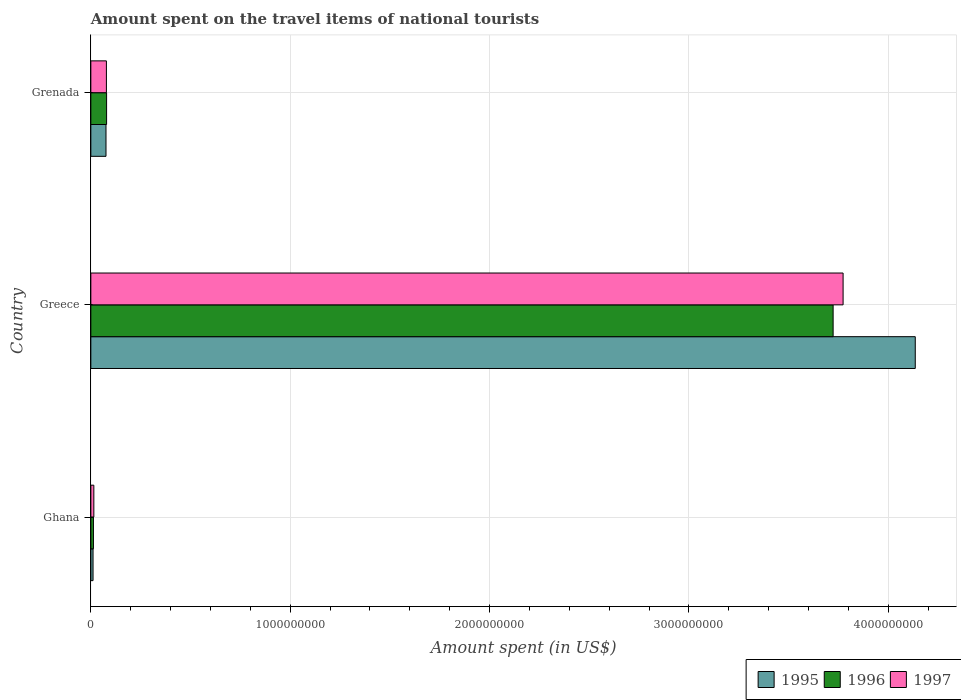How many different coloured bars are there?
Ensure brevity in your answer.  3. How many groups of bars are there?
Offer a very short reply. 3. How many bars are there on the 1st tick from the top?
Give a very brief answer. 3. How many bars are there on the 1st tick from the bottom?
Ensure brevity in your answer.  3. What is the label of the 1st group of bars from the top?
Offer a very short reply. Grenada. In how many cases, is the number of bars for a given country not equal to the number of legend labels?
Offer a terse response. 0. What is the amount spent on the travel items of national tourists in 1997 in Ghana?
Ensure brevity in your answer.  1.50e+07. Across all countries, what is the maximum amount spent on the travel items of national tourists in 1996?
Keep it short and to the point. 3.72e+09. Across all countries, what is the minimum amount spent on the travel items of national tourists in 1996?
Keep it short and to the point. 1.30e+07. In which country was the amount spent on the travel items of national tourists in 1997 minimum?
Provide a short and direct response. Ghana. What is the total amount spent on the travel items of national tourists in 1996 in the graph?
Make the answer very short. 3.82e+09. What is the difference between the amount spent on the travel items of national tourists in 1995 in Ghana and that in Greece?
Provide a succinct answer. -4.12e+09. What is the difference between the amount spent on the travel items of national tourists in 1997 in Greece and the amount spent on the travel items of national tourists in 1995 in Ghana?
Provide a succinct answer. 3.76e+09. What is the average amount spent on the travel items of national tourists in 1996 per country?
Offer a terse response. 1.27e+09. In how many countries, is the amount spent on the travel items of national tourists in 1996 greater than 1800000000 US$?
Your response must be concise. 1. What is the ratio of the amount spent on the travel items of national tourists in 1997 in Greece to that in Grenada?
Provide a short and direct response. 48.37. Is the amount spent on the travel items of national tourists in 1996 in Ghana less than that in Grenada?
Keep it short and to the point. Yes. What is the difference between the highest and the second highest amount spent on the travel items of national tourists in 1996?
Your answer should be very brief. 3.64e+09. What is the difference between the highest and the lowest amount spent on the travel items of national tourists in 1996?
Your response must be concise. 3.71e+09. In how many countries, is the amount spent on the travel items of national tourists in 1996 greater than the average amount spent on the travel items of national tourists in 1996 taken over all countries?
Provide a short and direct response. 1. What does the 2nd bar from the bottom in Ghana represents?
Your response must be concise. 1996. Are all the bars in the graph horizontal?
Offer a terse response. Yes. What is the difference between two consecutive major ticks on the X-axis?
Your answer should be very brief. 1.00e+09. Does the graph contain any zero values?
Your answer should be very brief. No. Does the graph contain grids?
Provide a short and direct response. Yes. How many legend labels are there?
Offer a terse response. 3. How are the legend labels stacked?
Make the answer very short. Horizontal. What is the title of the graph?
Provide a succinct answer. Amount spent on the travel items of national tourists. What is the label or title of the X-axis?
Keep it short and to the point. Amount spent (in US$). What is the Amount spent (in US$) of 1995 in Ghana?
Your answer should be very brief. 1.10e+07. What is the Amount spent (in US$) in 1996 in Ghana?
Give a very brief answer. 1.30e+07. What is the Amount spent (in US$) in 1997 in Ghana?
Your response must be concise. 1.50e+07. What is the Amount spent (in US$) in 1995 in Greece?
Ensure brevity in your answer.  4.14e+09. What is the Amount spent (in US$) of 1996 in Greece?
Offer a terse response. 3.72e+09. What is the Amount spent (in US$) in 1997 in Greece?
Your response must be concise. 3.77e+09. What is the Amount spent (in US$) of 1995 in Grenada?
Your response must be concise. 7.60e+07. What is the Amount spent (in US$) of 1996 in Grenada?
Offer a very short reply. 7.90e+07. What is the Amount spent (in US$) of 1997 in Grenada?
Your answer should be compact. 7.80e+07. Across all countries, what is the maximum Amount spent (in US$) of 1995?
Ensure brevity in your answer.  4.14e+09. Across all countries, what is the maximum Amount spent (in US$) in 1996?
Offer a very short reply. 3.72e+09. Across all countries, what is the maximum Amount spent (in US$) in 1997?
Your response must be concise. 3.77e+09. Across all countries, what is the minimum Amount spent (in US$) in 1995?
Your response must be concise. 1.10e+07. Across all countries, what is the minimum Amount spent (in US$) of 1996?
Give a very brief answer. 1.30e+07. Across all countries, what is the minimum Amount spent (in US$) in 1997?
Provide a short and direct response. 1.50e+07. What is the total Amount spent (in US$) of 1995 in the graph?
Give a very brief answer. 4.22e+09. What is the total Amount spent (in US$) in 1996 in the graph?
Your answer should be very brief. 3.82e+09. What is the total Amount spent (in US$) of 1997 in the graph?
Your response must be concise. 3.87e+09. What is the difference between the Amount spent (in US$) in 1995 in Ghana and that in Greece?
Your answer should be very brief. -4.12e+09. What is the difference between the Amount spent (in US$) of 1996 in Ghana and that in Greece?
Keep it short and to the point. -3.71e+09. What is the difference between the Amount spent (in US$) in 1997 in Ghana and that in Greece?
Ensure brevity in your answer.  -3.76e+09. What is the difference between the Amount spent (in US$) of 1995 in Ghana and that in Grenada?
Provide a short and direct response. -6.50e+07. What is the difference between the Amount spent (in US$) of 1996 in Ghana and that in Grenada?
Make the answer very short. -6.60e+07. What is the difference between the Amount spent (in US$) in 1997 in Ghana and that in Grenada?
Your answer should be compact. -6.30e+07. What is the difference between the Amount spent (in US$) in 1995 in Greece and that in Grenada?
Your answer should be compact. 4.06e+09. What is the difference between the Amount spent (in US$) of 1996 in Greece and that in Grenada?
Make the answer very short. 3.64e+09. What is the difference between the Amount spent (in US$) of 1997 in Greece and that in Grenada?
Your answer should be compact. 3.70e+09. What is the difference between the Amount spent (in US$) in 1995 in Ghana and the Amount spent (in US$) in 1996 in Greece?
Your answer should be very brief. -3.71e+09. What is the difference between the Amount spent (in US$) in 1995 in Ghana and the Amount spent (in US$) in 1997 in Greece?
Offer a terse response. -3.76e+09. What is the difference between the Amount spent (in US$) in 1996 in Ghana and the Amount spent (in US$) in 1997 in Greece?
Give a very brief answer. -3.76e+09. What is the difference between the Amount spent (in US$) of 1995 in Ghana and the Amount spent (in US$) of 1996 in Grenada?
Provide a short and direct response. -6.80e+07. What is the difference between the Amount spent (in US$) of 1995 in Ghana and the Amount spent (in US$) of 1997 in Grenada?
Your response must be concise. -6.70e+07. What is the difference between the Amount spent (in US$) of 1996 in Ghana and the Amount spent (in US$) of 1997 in Grenada?
Provide a succinct answer. -6.50e+07. What is the difference between the Amount spent (in US$) of 1995 in Greece and the Amount spent (in US$) of 1996 in Grenada?
Make the answer very short. 4.06e+09. What is the difference between the Amount spent (in US$) of 1995 in Greece and the Amount spent (in US$) of 1997 in Grenada?
Your response must be concise. 4.06e+09. What is the difference between the Amount spent (in US$) of 1996 in Greece and the Amount spent (in US$) of 1997 in Grenada?
Provide a short and direct response. 3.64e+09. What is the average Amount spent (in US$) in 1995 per country?
Offer a terse response. 1.41e+09. What is the average Amount spent (in US$) in 1996 per country?
Provide a succinct answer. 1.27e+09. What is the average Amount spent (in US$) in 1997 per country?
Give a very brief answer. 1.29e+09. What is the difference between the Amount spent (in US$) of 1995 and Amount spent (in US$) of 1996 in Ghana?
Keep it short and to the point. -2.00e+06. What is the difference between the Amount spent (in US$) in 1995 and Amount spent (in US$) in 1997 in Ghana?
Your answer should be very brief. -4.00e+06. What is the difference between the Amount spent (in US$) of 1995 and Amount spent (in US$) of 1996 in Greece?
Your answer should be compact. 4.12e+08. What is the difference between the Amount spent (in US$) in 1995 and Amount spent (in US$) in 1997 in Greece?
Your answer should be very brief. 3.62e+08. What is the difference between the Amount spent (in US$) of 1996 and Amount spent (in US$) of 1997 in Greece?
Give a very brief answer. -5.00e+07. What is the difference between the Amount spent (in US$) of 1995 and Amount spent (in US$) of 1996 in Grenada?
Your response must be concise. -3.00e+06. What is the difference between the Amount spent (in US$) of 1996 and Amount spent (in US$) of 1997 in Grenada?
Your answer should be very brief. 1.00e+06. What is the ratio of the Amount spent (in US$) of 1995 in Ghana to that in Greece?
Your answer should be very brief. 0. What is the ratio of the Amount spent (in US$) of 1996 in Ghana to that in Greece?
Your answer should be compact. 0. What is the ratio of the Amount spent (in US$) in 1997 in Ghana to that in Greece?
Provide a short and direct response. 0. What is the ratio of the Amount spent (in US$) in 1995 in Ghana to that in Grenada?
Your answer should be compact. 0.14. What is the ratio of the Amount spent (in US$) in 1996 in Ghana to that in Grenada?
Offer a very short reply. 0.16. What is the ratio of the Amount spent (in US$) in 1997 in Ghana to that in Grenada?
Make the answer very short. 0.19. What is the ratio of the Amount spent (in US$) in 1995 in Greece to that in Grenada?
Provide a succinct answer. 54.41. What is the ratio of the Amount spent (in US$) of 1996 in Greece to that in Grenada?
Ensure brevity in your answer.  47.13. What is the ratio of the Amount spent (in US$) in 1997 in Greece to that in Grenada?
Ensure brevity in your answer.  48.37. What is the difference between the highest and the second highest Amount spent (in US$) in 1995?
Keep it short and to the point. 4.06e+09. What is the difference between the highest and the second highest Amount spent (in US$) in 1996?
Provide a succinct answer. 3.64e+09. What is the difference between the highest and the second highest Amount spent (in US$) in 1997?
Keep it short and to the point. 3.70e+09. What is the difference between the highest and the lowest Amount spent (in US$) of 1995?
Offer a terse response. 4.12e+09. What is the difference between the highest and the lowest Amount spent (in US$) in 1996?
Ensure brevity in your answer.  3.71e+09. What is the difference between the highest and the lowest Amount spent (in US$) of 1997?
Offer a very short reply. 3.76e+09. 